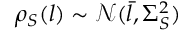Convert formula to latex. <formula><loc_0><loc_0><loc_500><loc_500>\rho _ { S } ( l ) \sim \mathcal { N } ( \bar { l } , \Sigma _ { S } ^ { 2 } )</formula> 